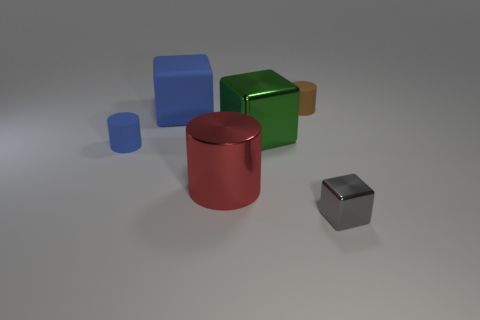Is the number of big matte blocks that are on the right side of the small brown rubber cylinder greater than the number of gray metallic blocks on the left side of the large green metallic cube?
Your answer should be compact. No. Is the color of the thing that is to the right of the brown rubber object the same as the big metal cube?
Your answer should be very brief. No. What size is the blue matte cylinder?
Ensure brevity in your answer.  Small. What is the material of the blue object that is the same size as the green thing?
Offer a terse response. Rubber. The rubber object in front of the green thing is what color?
Your response must be concise. Blue. What number of tiny green cylinders are there?
Provide a succinct answer. 0. There is a small cylinder on the left side of the metallic thing behind the red thing; are there any big red metal cylinders that are on the left side of it?
Ensure brevity in your answer.  No. There is a brown matte thing that is the same size as the gray object; what is its shape?
Provide a succinct answer. Cylinder. What number of other things are the same color as the metallic cylinder?
Keep it short and to the point. 0. What is the material of the red object?
Provide a short and direct response. Metal. 